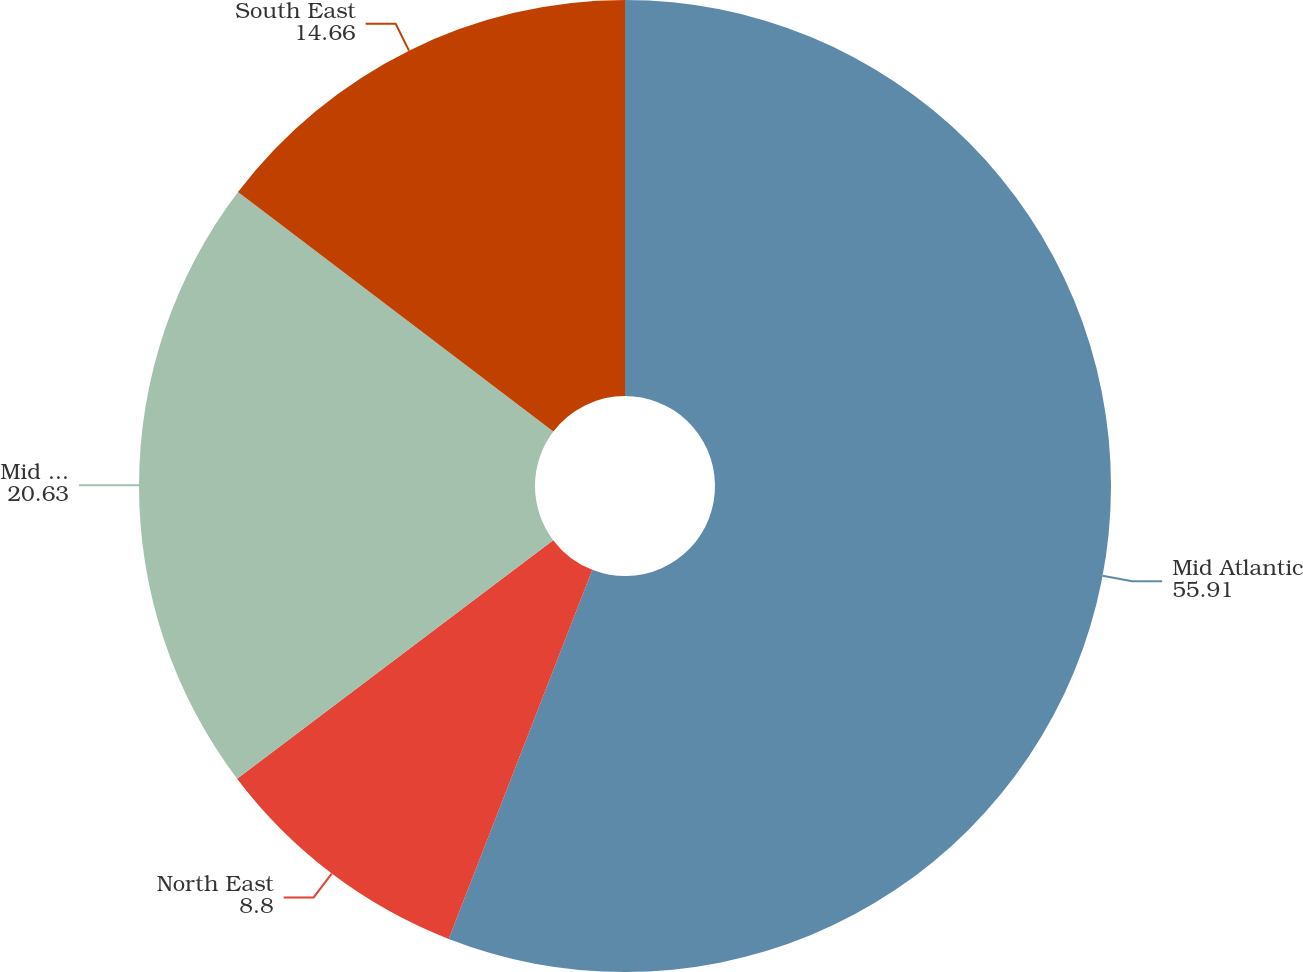<chart> <loc_0><loc_0><loc_500><loc_500><pie_chart><fcel>Mid Atlantic<fcel>North East<fcel>Mid East<fcel>South East<nl><fcel>55.91%<fcel>8.8%<fcel>20.63%<fcel>14.66%<nl></chart> 